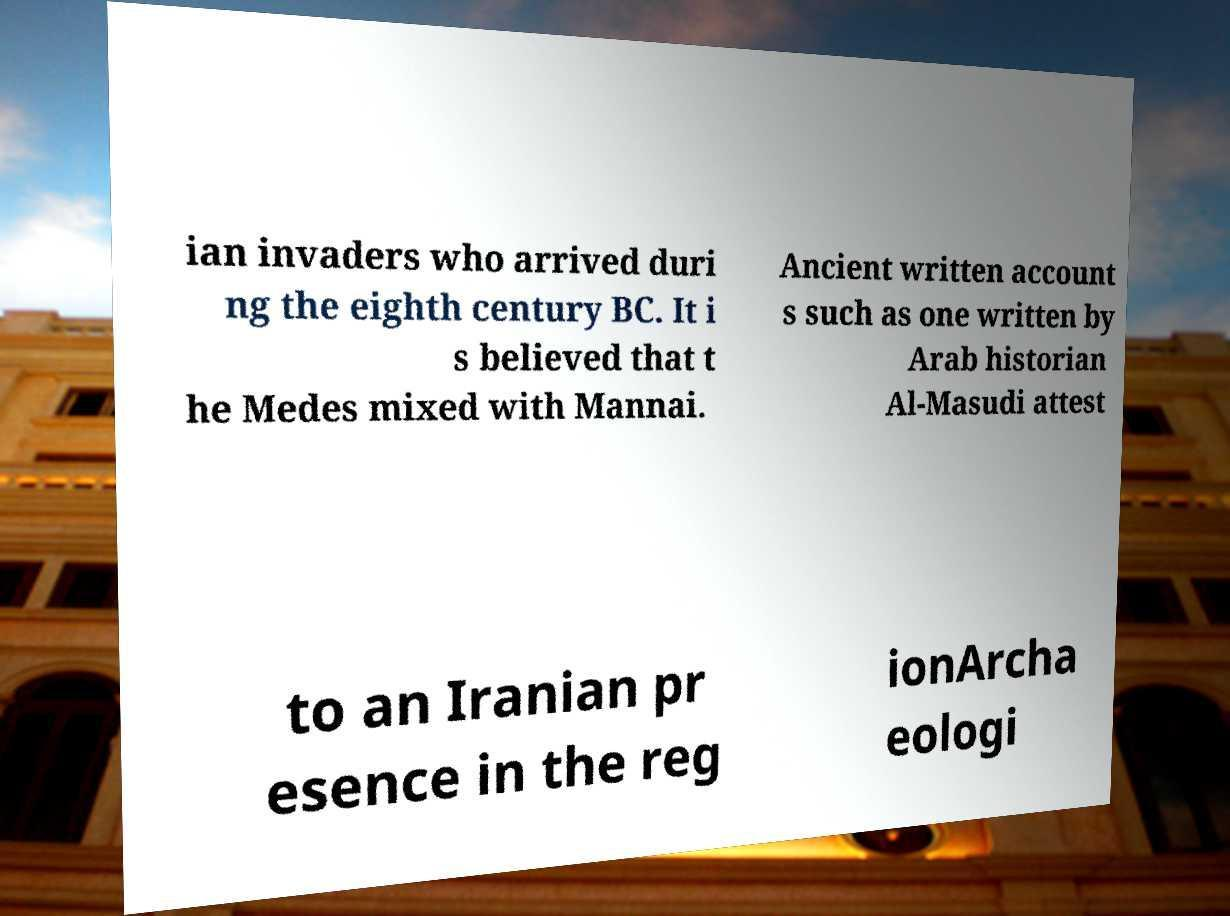Can you accurately transcribe the text from the provided image for me? ian invaders who arrived duri ng the eighth century BC. It i s believed that t he Medes mixed with Mannai. Ancient written account s such as one written by Arab historian Al-Masudi attest to an Iranian pr esence in the reg ionArcha eologi 